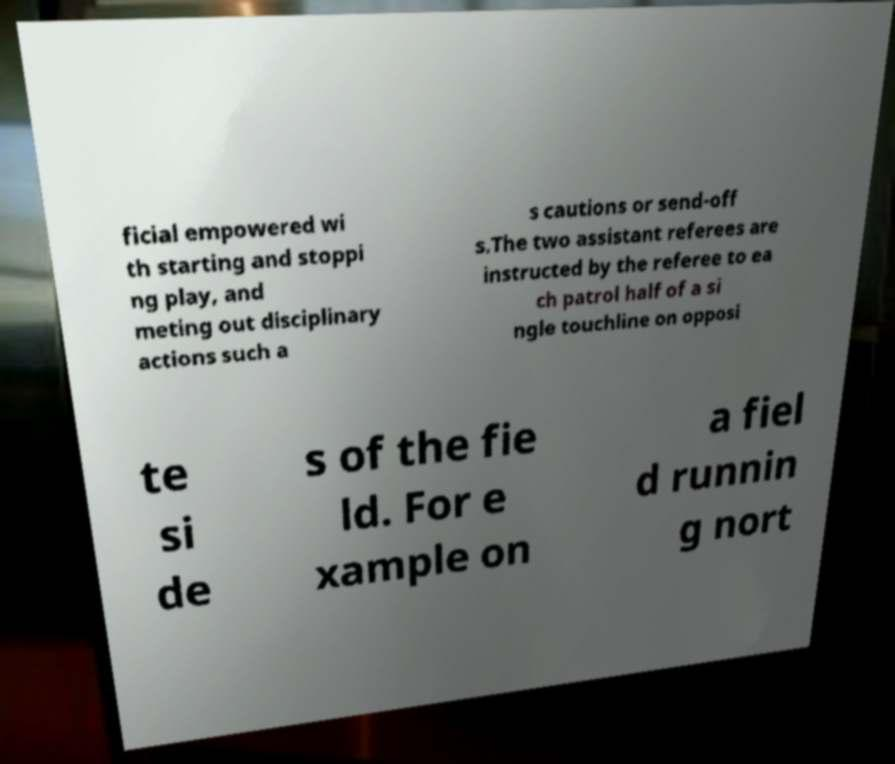Could you extract and type out the text from this image? ficial empowered wi th starting and stoppi ng play, and meting out disciplinary actions such a s cautions or send-off s.The two assistant referees are instructed by the referee to ea ch patrol half of a si ngle touchline on opposi te si de s of the fie ld. For e xample on a fiel d runnin g nort 